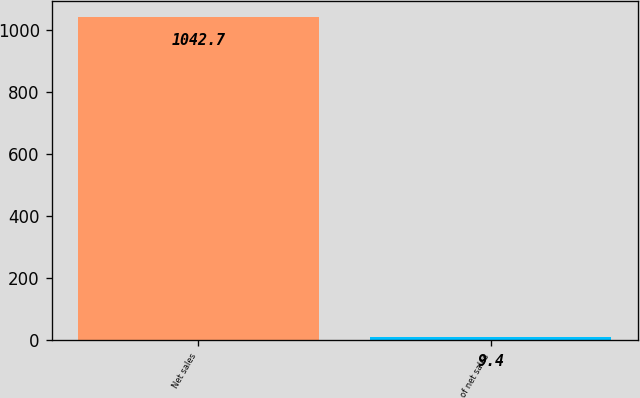Convert chart. <chart><loc_0><loc_0><loc_500><loc_500><bar_chart><fcel>Net sales<fcel>of net sales<nl><fcel>1042.7<fcel>9.4<nl></chart> 